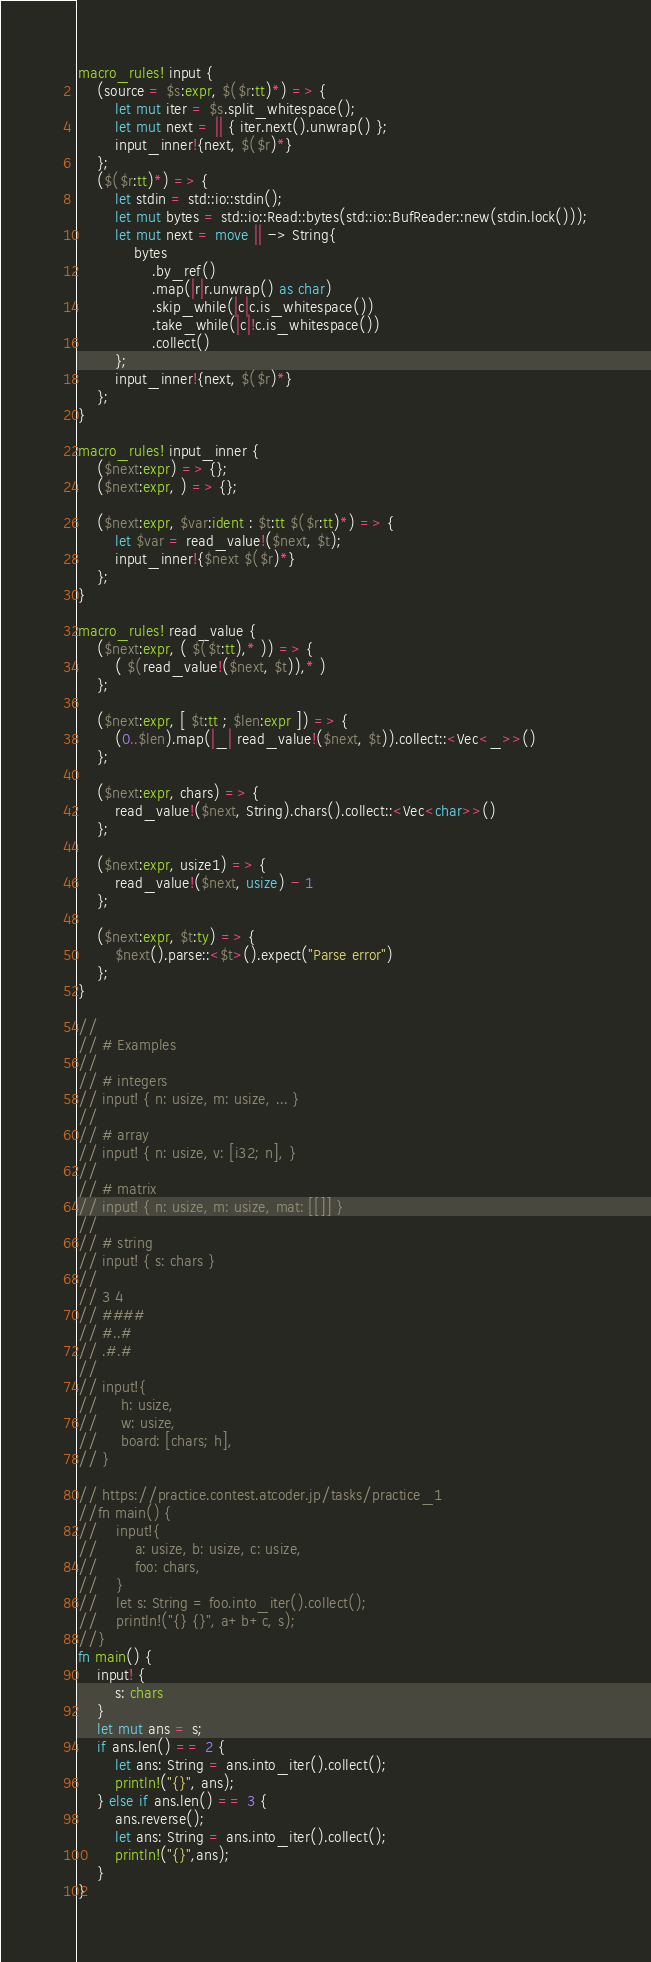Convert code to text. <code><loc_0><loc_0><loc_500><loc_500><_Rust_>macro_rules! input {
    (source = $s:expr, $($r:tt)*) => {
        let mut iter = $s.split_whitespace();
        let mut next = || { iter.next().unwrap() };
        input_inner!{next, $($r)*}
    };
    ($($r:tt)*) => {
        let stdin = std::io::stdin();
        let mut bytes = std::io::Read::bytes(std::io::BufReader::new(stdin.lock()));
        let mut next = move || -> String{
            bytes
                .by_ref()
                .map(|r|r.unwrap() as char)
                .skip_while(|c|c.is_whitespace())
                .take_while(|c|!c.is_whitespace())
                .collect()
        };
        input_inner!{next, $($r)*}
    };
}

macro_rules! input_inner {
    ($next:expr) => {};
    ($next:expr, ) => {};

    ($next:expr, $var:ident : $t:tt $($r:tt)*) => {
        let $var = read_value!($next, $t);
        input_inner!{$next $($r)*}
    };
}

macro_rules! read_value {
    ($next:expr, ( $($t:tt),* )) => {
        ( $(read_value!($next, $t)),* )
    };

    ($next:expr, [ $t:tt ; $len:expr ]) => {
        (0..$len).map(|_| read_value!($next, $t)).collect::<Vec<_>>()
    };

    ($next:expr, chars) => {
        read_value!($next, String).chars().collect::<Vec<char>>()
    };

    ($next:expr, usize1) => {
        read_value!($next, usize) - 1
    };

    ($next:expr, $t:ty) => {
        $next().parse::<$t>().expect("Parse error")
    };
}

//
// # Examples
//
// # integers
// input! { n: usize, m: usize, ... }
//
// # array
// input! { n: usize, v: [i32; n], }
//
// # matrix
// input! { n: usize, m: usize, mat: [[]] }
//
// # string
// input! { s: chars }
//
// 3 4
// ####
// #..#
// .#.#
//
// input!{
//     h: usize,
//     w: usize,
//     board: [chars; h],
// }

// https://practice.contest.atcoder.jp/tasks/practice_1
//fn main() {
//    input!{
//        a: usize, b: usize, c: usize,
//        foo: chars,
//    }
//    let s: String = foo.into_iter().collect();
//    println!("{} {}", a+b+c, s);
//}
fn main() {
    input! {
        s: chars
    }
    let mut ans = s;
    if ans.len() == 2 {
        let ans: String = ans.into_iter().collect();
        println!("{}", ans);
    } else if ans.len() == 3 {
        ans.reverse();
        let ans: String = ans.into_iter().collect();
        println!("{}",ans);
    }
}</code> 